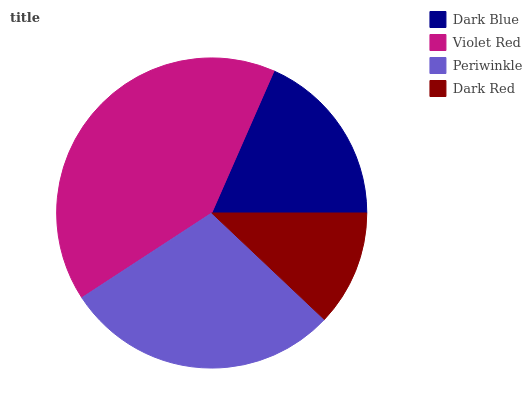Is Dark Red the minimum?
Answer yes or no. Yes. Is Violet Red the maximum?
Answer yes or no. Yes. Is Periwinkle the minimum?
Answer yes or no. No. Is Periwinkle the maximum?
Answer yes or no. No. Is Violet Red greater than Periwinkle?
Answer yes or no. Yes. Is Periwinkle less than Violet Red?
Answer yes or no. Yes. Is Periwinkle greater than Violet Red?
Answer yes or no. No. Is Violet Red less than Periwinkle?
Answer yes or no. No. Is Periwinkle the high median?
Answer yes or no. Yes. Is Dark Blue the low median?
Answer yes or no. Yes. Is Dark Red the high median?
Answer yes or no. No. Is Dark Red the low median?
Answer yes or no. No. 